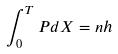<formula> <loc_0><loc_0><loc_500><loc_500>\int _ { 0 } ^ { T } P d X = n h</formula> 